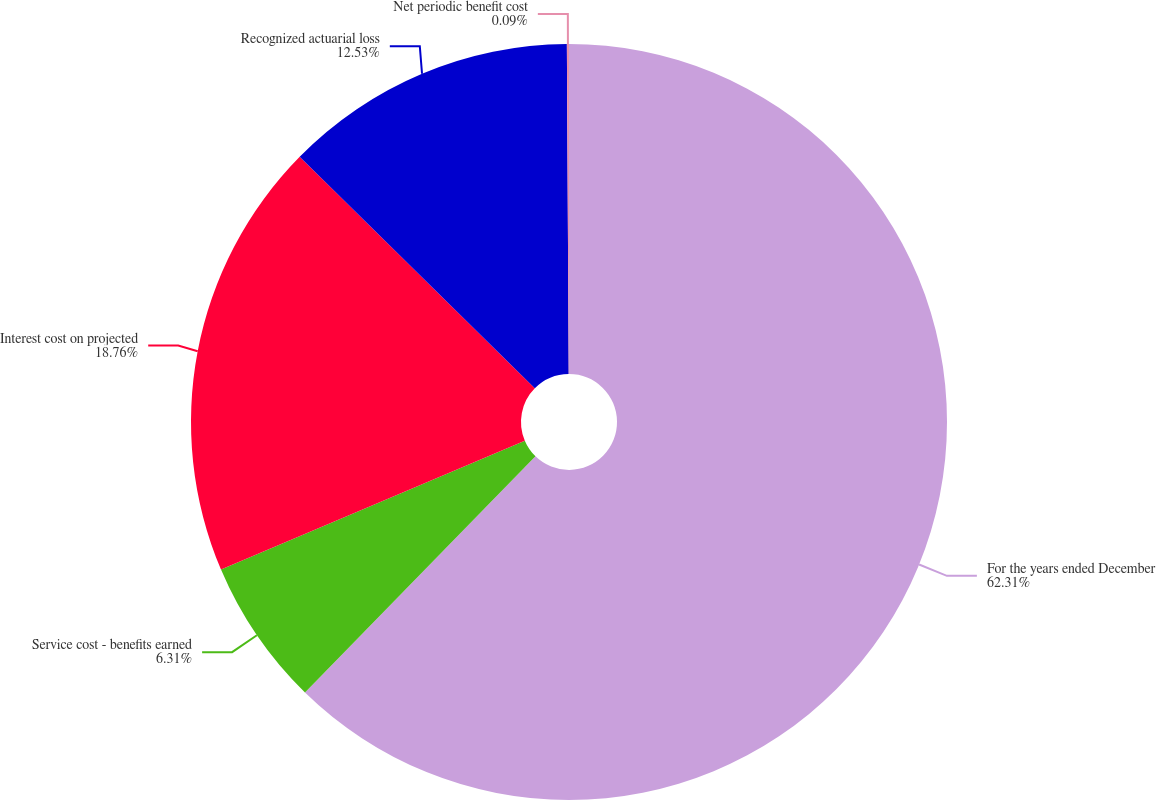<chart> <loc_0><loc_0><loc_500><loc_500><pie_chart><fcel>For the years ended December<fcel>Service cost - benefits earned<fcel>Interest cost on projected<fcel>Recognized actuarial loss<fcel>Net periodic benefit cost<nl><fcel>62.3%<fcel>6.31%<fcel>18.76%<fcel>12.53%<fcel>0.09%<nl></chart> 